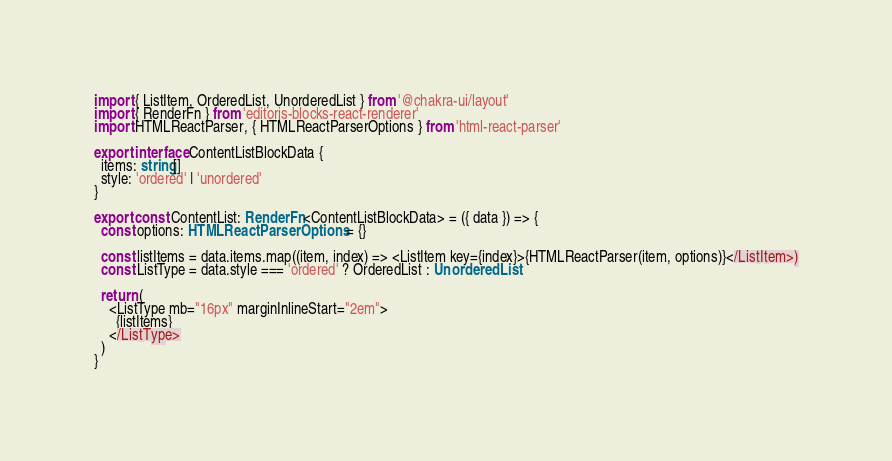Convert code to text. <code><loc_0><loc_0><loc_500><loc_500><_TypeScript_>import { ListItem, OrderedList, UnorderedList } from '@chakra-ui/layout'
import { RenderFn } from 'editorjs-blocks-react-renderer'
import HTMLReactParser, { HTMLReactParserOptions } from 'html-react-parser'

export interface ContentListBlockData {
  items: string[]
  style: 'ordered' | 'unordered'
}

export const ContentList: RenderFn<ContentListBlockData> = ({ data }) => {
  const options: HTMLReactParserOptions = {}

  const listItems = data.items.map((item, index) => <ListItem key={index}>{HTMLReactParser(item, options)}</ListItem>)
  const ListType = data.style === 'ordered' ? OrderedList : UnorderedList

  return (
    <ListType mb="16px" marginInlineStart="2em">
      {listItems}
    </ListType>
  )
}
</code> 